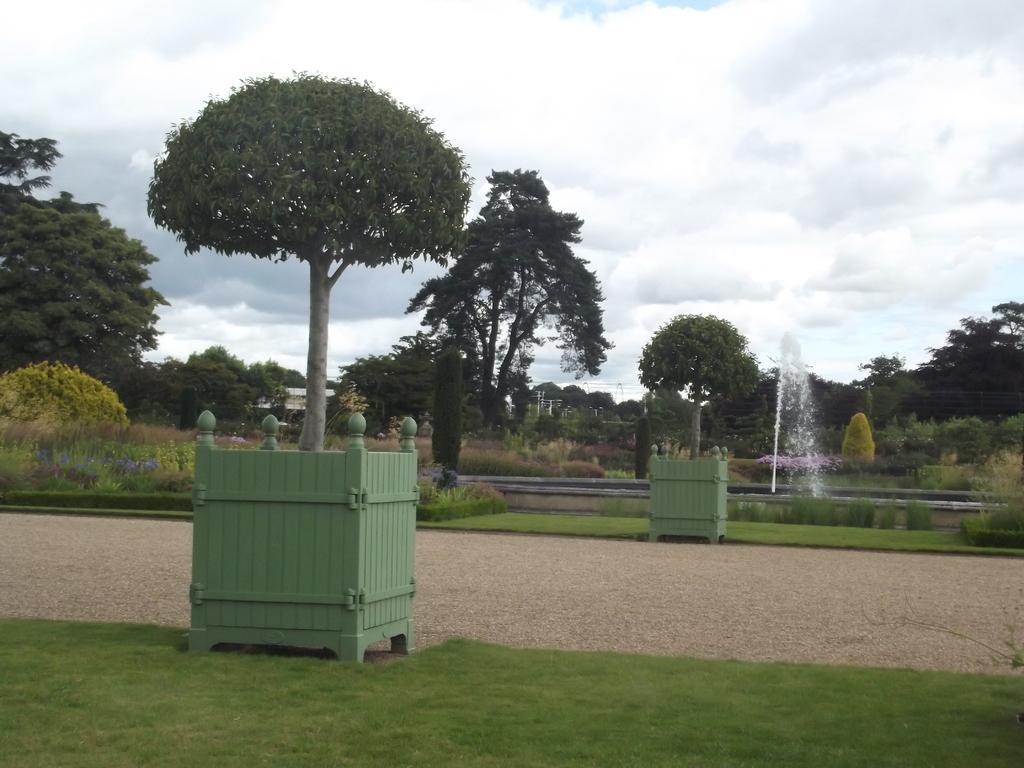In one or two sentences, can you explain what this image depicts? In this picture we can see grass, plants, trees, water, flowers and green objects. In the background of the image we can see the sky with clouds. 